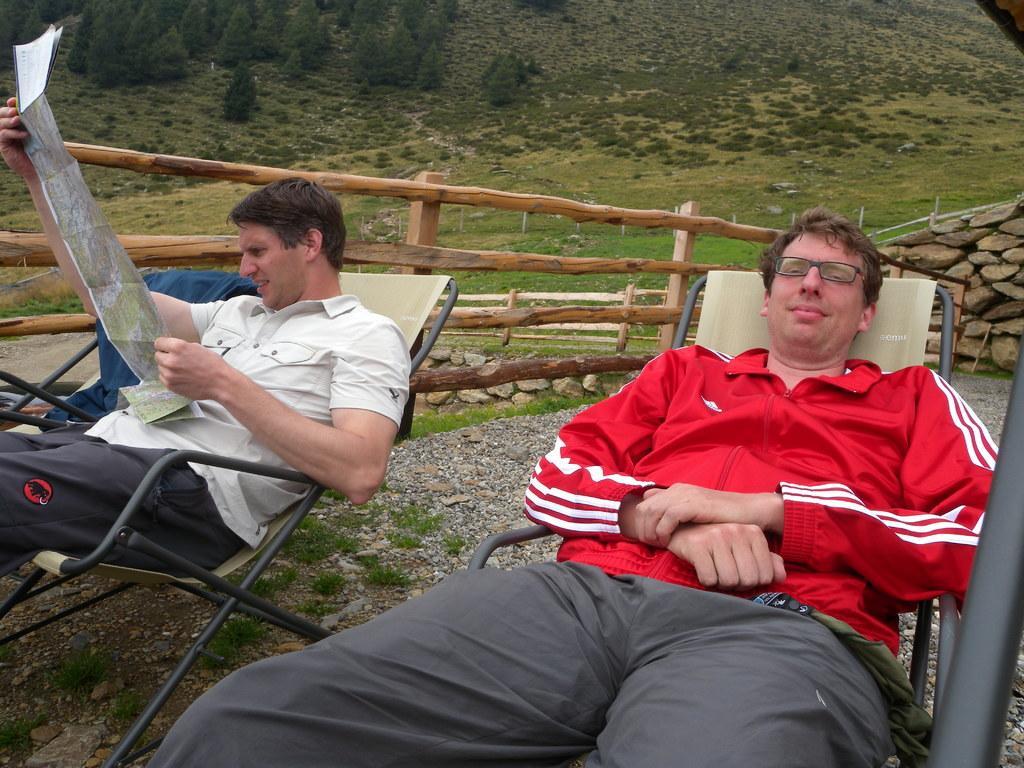How would you summarize this image in a sentence or two? In this image i can see two men who are lying on a chair, the person left side is holding a paper, behind him we have a wooden fence. 